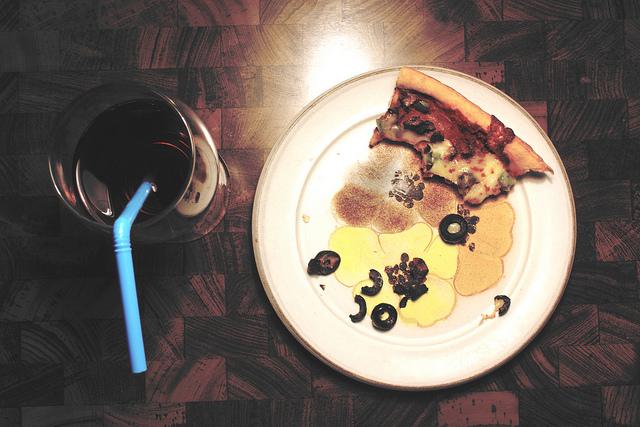Where are the black olive slices?
Be succinct. On plate. What color is the straw?
Answer briefly. Blue. What type of food is this?
Keep it brief. Pizza. 